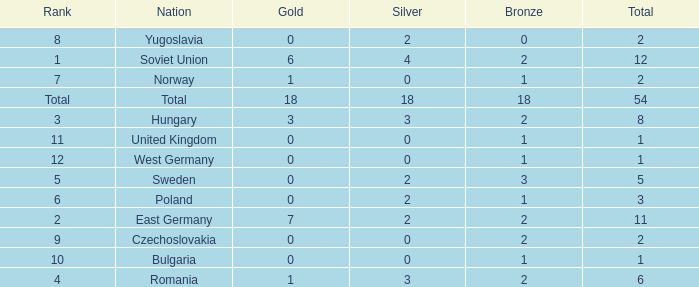What's the highest total of Romania when the bronze was less than 2? None. 